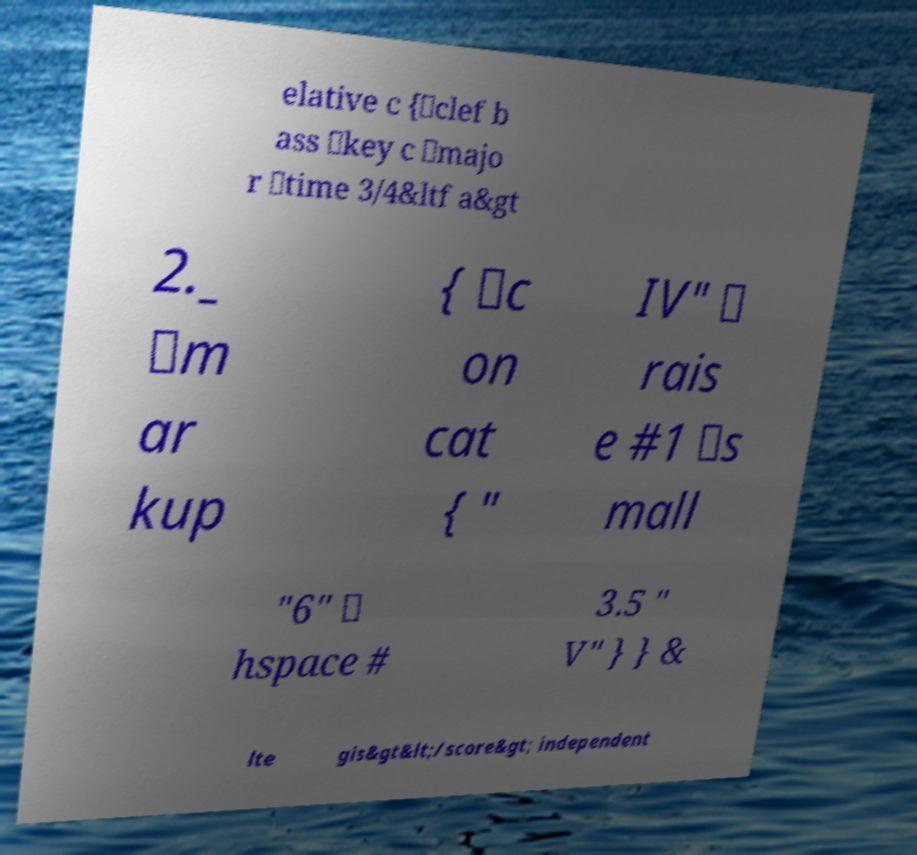There's text embedded in this image that I need extracted. Can you transcribe it verbatim? elative c {\clef b ass \key c \majo r \time 3/4&ltf a&gt 2._ \m ar kup { \c on cat { " IV" \ rais e #1 \s mall "6" \ hspace # 3.5 " V" } } & lte gis&gt&lt;/score&gt; independent 